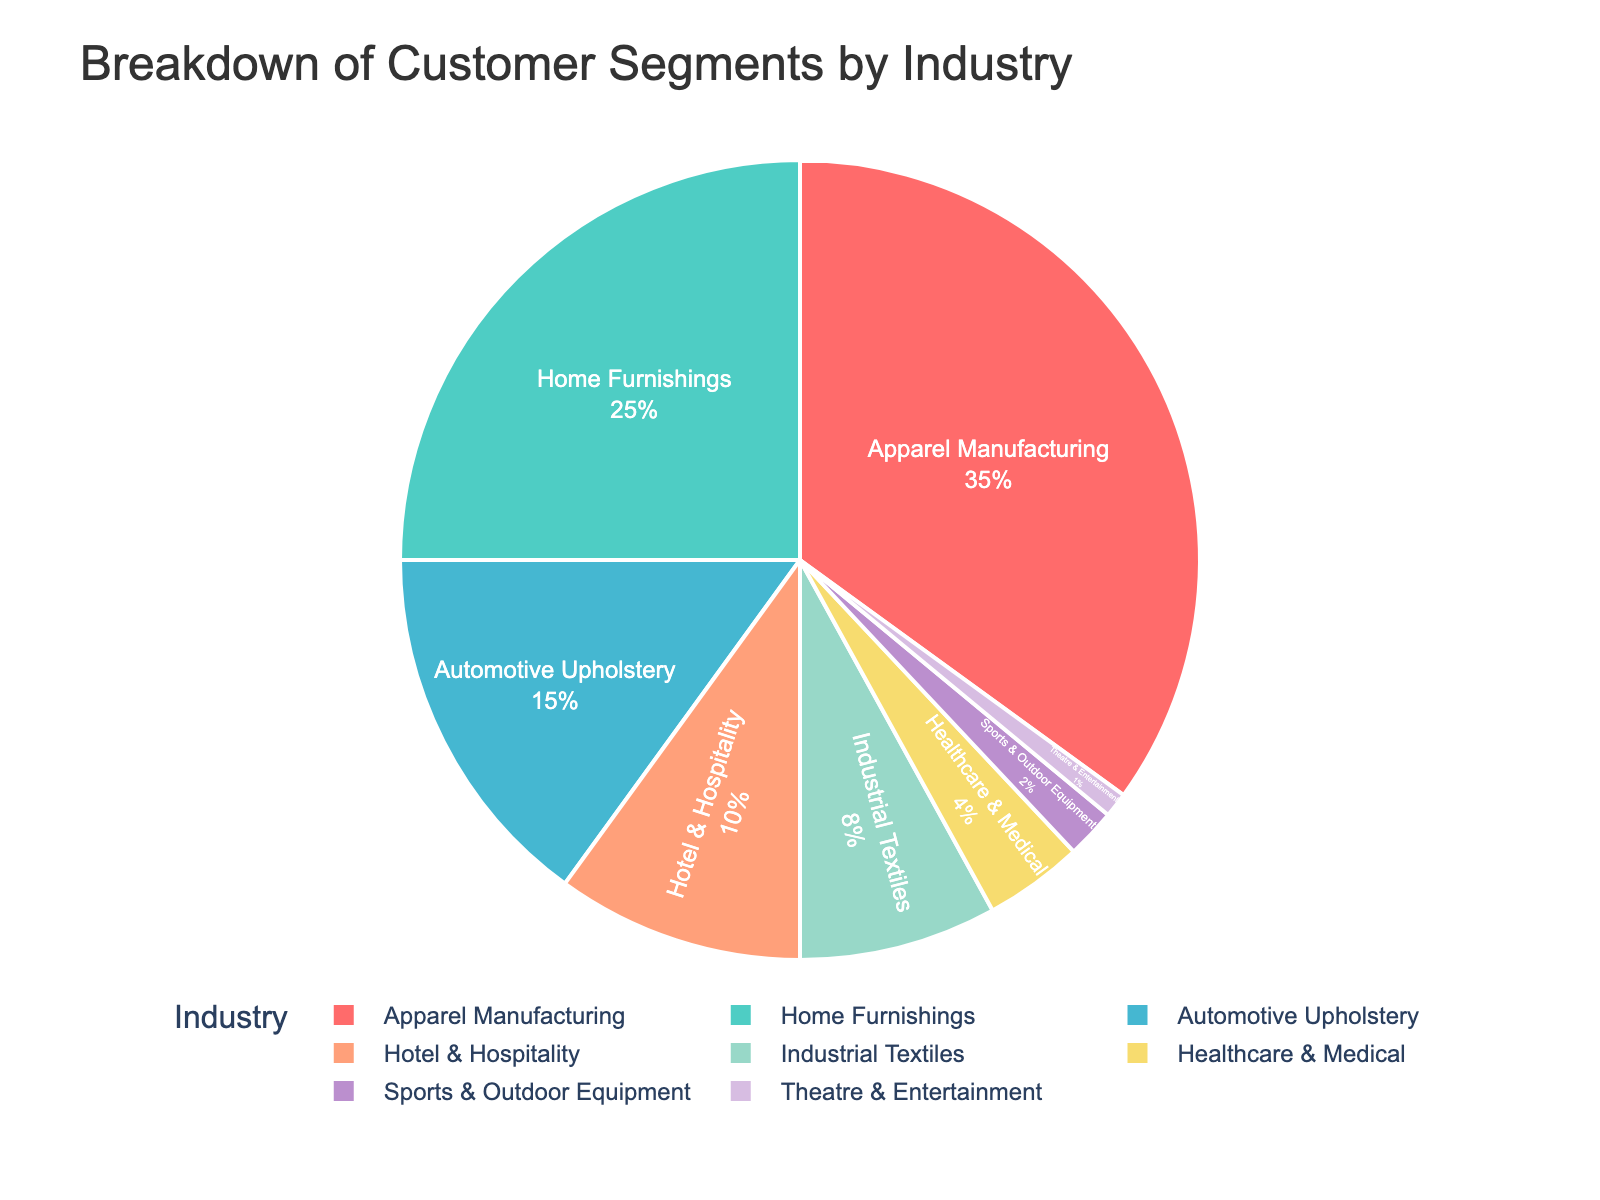What is the largest customer segment by industry? The figure shows the breakdown of customer segments by industry, and the segment with the largest percentage indicates the largest customer segment. The Apparel Manufacturing segment occupies 35% of the pie chart, making it the largest customer segment.
Answer: Apparel Manufacturing What are the total percentage values for the Home Furnishings and Automotive Upholstery segments combined? To find the total percentage for the Home Furnishings and Automotive Upholstery segments, sum their respective percentages: Home Furnishings (25%) + Automotive Upholstery (15%) = 40%.
Answer: 40% Which customer segment has a smaller percentage: Healthcare & Medical or Sports & Outdoor Equipment? By comparing the percentages of the two segments, Healthcare & Medical has 4% and Sports & Outdoor Equipment has 2%. Sports & Outdoor Equipment has the smaller percentage.
Answer: Sports & Outdoor Equipment How much larger is the Apparel Manufacturing segment compared to the Hotel & Hospitality segment? To determine the difference in percentage between the Apparel Manufacturing and Hotel & Hospitality segments, subtract the percentage of Hotel & Hospitality (10%) from Apparel Manufacturing (35%): 35% - 10% = 25%. The Apparel Manufacturing segment is 25% larger.
Answer: 25% What is the combined total percentage for all segments except Apparel Manufacturing? To find the combined percentage of all segments excluding Apparel Manufacturing, sum the percentages of the remaining segments: Home Furnishings (25%) + Automotive Upholstery (15%) + Hotel & Hospitality (10%) + Industrial Textiles (8%) + Healthcare & Medical (4%) + Sports & Outdoor Equipment (2%) + Theatre & Entertainment (1%) = 65%.
Answer: 65% How does the percentage of the Industrial Textiles segment compare to that of the Theatre & Entertainment segment? The percentage for the Industrial Textiles segment (8%) is much larger than the Theatre & Entertainment segment (1%).
Answer: Industrial Textiles is larger Which segment has a percentage closest to 10%? The Hotel & Hospitality segment has a percentage closest to 10%, as it is exactly 10%.
Answer: Hotel & Hospitality Which segments together make up less than 10% of the total? By examining the segments with percentages less than 10%, Theatre & Entertainment (1%), Sports & Outdoor Equipment (2%), Healthcare & Medical (4%), and Industrial Textiles (8%) are considered. Adding their percentages: 1% + 2% + 4% + 8% = 15%, thus only Theatre & Entertainment and Sports & Outdoor Equipment together make up less than 10%.
Answer: Theatre & Entertainment and Sports & Outdoor Equipment What's the difference in the percentage between the Home Furnishings and Industrial Textiles segments? Subtract the percentage of the Industrial Textiles segment (8%) from the Home Furnishings segment (25%): 25% - 8% = 17%. The difference is 17%.
Answer: 17% What is the total percentage contributed by the top three segments? Sum the percentages of the top three segments (Apparel Manufacturing, Home Furnishings, and Automotive Upholstery): Apparel Manufacturing (35%) + Home Furnishings (25%) + Automotive Upholstery (15%) = 75%.
Answer: 75% 